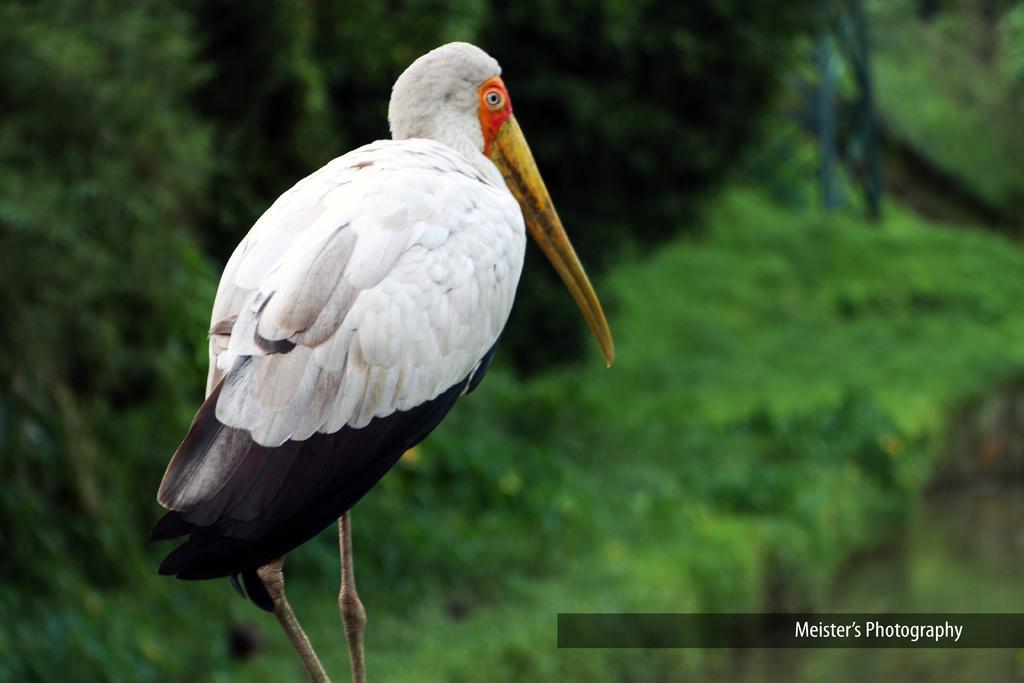Could you give a brief overview of what you see in this image? In the image we can see a bird, white, black, yellow and orange colors. At the right bottom we can see watermark. The background is greenish blurred. 